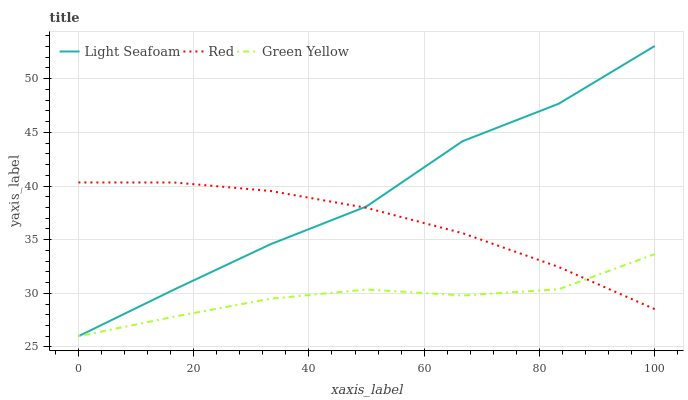Does Green Yellow have the minimum area under the curve?
Answer yes or no. Yes. Does Light Seafoam have the maximum area under the curve?
Answer yes or no. Yes. Does Red have the minimum area under the curve?
Answer yes or no. No. Does Red have the maximum area under the curve?
Answer yes or no. No. Is Red the smoothest?
Answer yes or no. Yes. Is Light Seafoam the roughest?
Answer yes or no. Yes. Is Light Seafoam the smoothest?
Answer yes or no. No. Is Red the roughest?
Answer yes or no. No. Does Green Yellow have the lowest value?
Answer yes or no. Yes. Does Red have the lowest value?
Answer yes or no. No. Does Light Seafoam have the highest value?
Answer yes or no. Yes. Does Red have the highest value?
Answer yes or no. No. Does Red intersect Light Seafoam?
Answer yes or no. Yes. Is Red less than Light Seafoam?
Answer yes or no. No. Is Red greater than Light Seafoam?
Answer yes or no. No. 